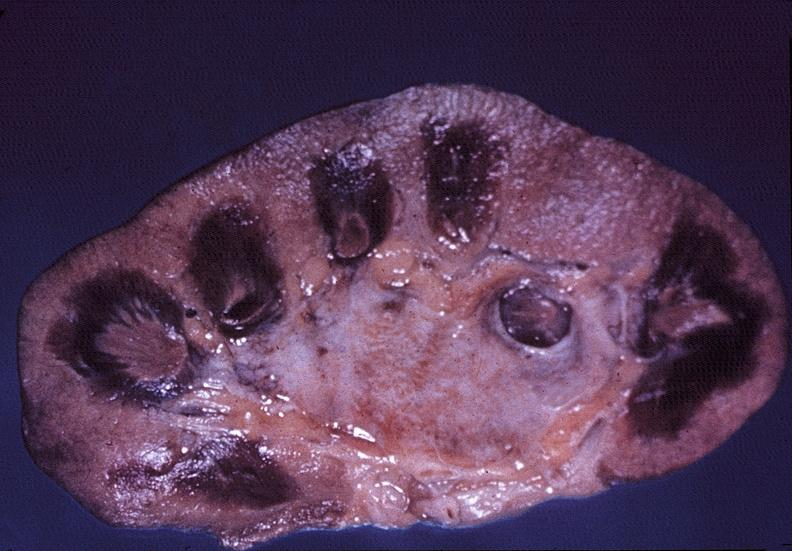s kidney, papillitis, necrotizing?
Answer the question using a single word or phrase. Yes 